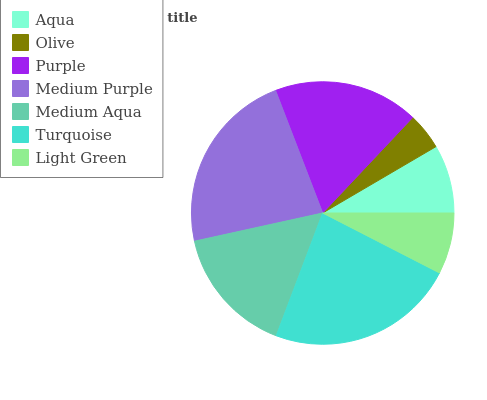Is Olive the minimum?
Answer yes or no. Yes. Is Turquoise the maximum?
Answer yes or no. Yes. Is Purple the minimum?
Answer yes or no. No. Is Purple the maximum?
Answer yes or no. No. Is Purple greater than Olive?
Answer yes or no. Yes. Is Olive less than Purple?
Answer yes or no. Yes. Is Olive greater than Purple?
Answer yes or no. No. Is Purple less than Olive?
Answer yes or no. No. Is Medium Aqua the high median?
Answer yes or no. Yes. Is Medium Aqua the low median?
Answer yes or no. Yes. Is Purple the high median?
Answer yes or no. No. Is Turquoise the low median?
Answer yes or no. No. 